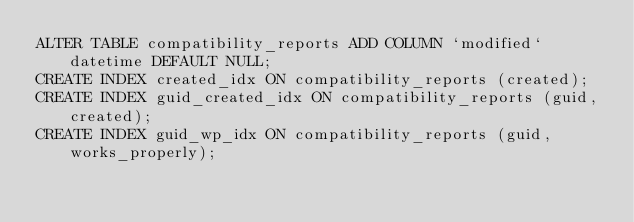<code> <loc_0><loc_0><loc_500><loc_500><_SQL_>ALTER TABLE compatibility_reports ADD COLUMN `modified` datetime DEFAULT NULL;
CREATE INDEX created_idx ON compatibility_reports (created);
CREATE INDEX guid_created_idx ON compatibility_reports (guid, created);
CREATE INDEX guid_wp_idx ON compatibility_reports (guid, works_properly);
</code> 